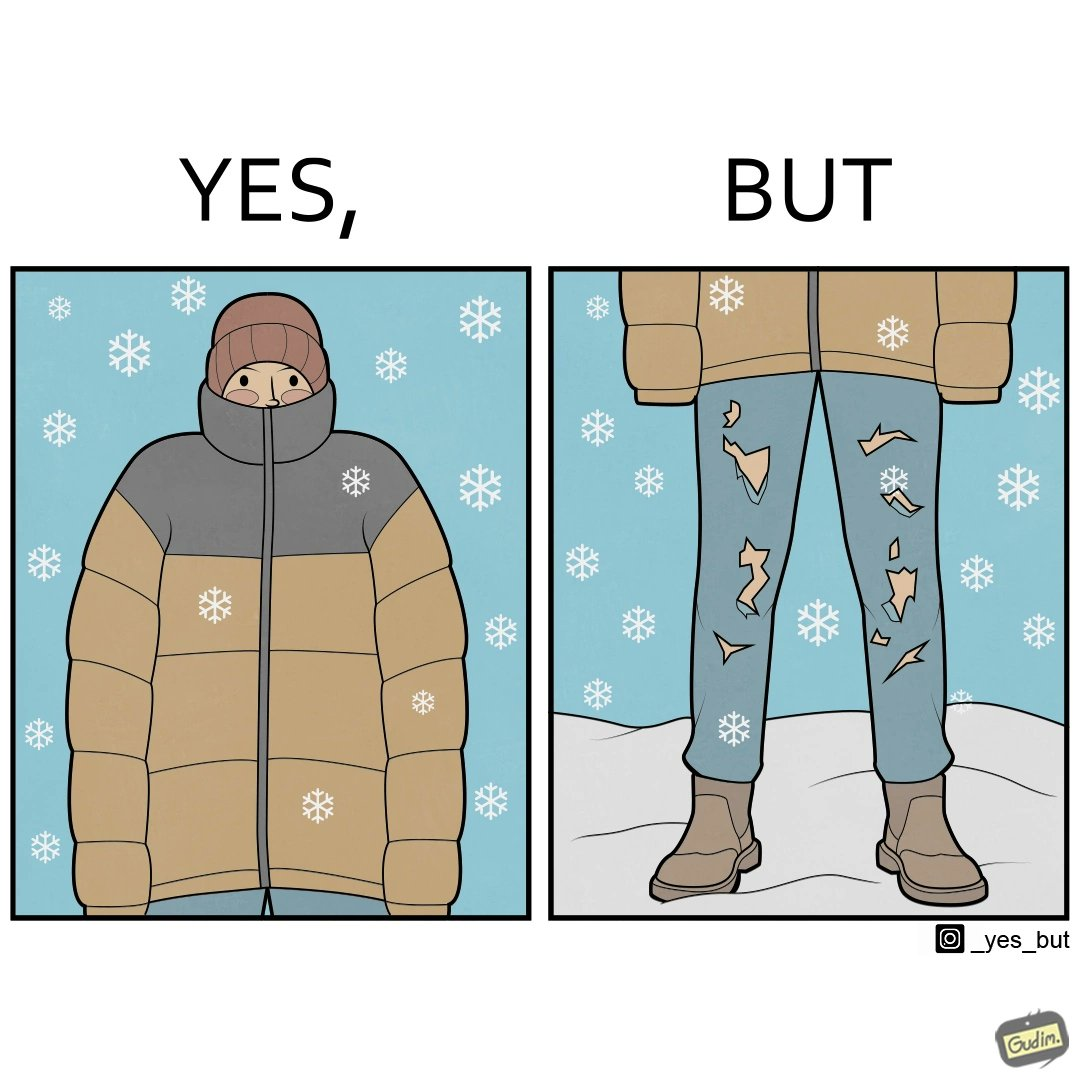Is there satirical content in this image? Yes, this image is satirical. 